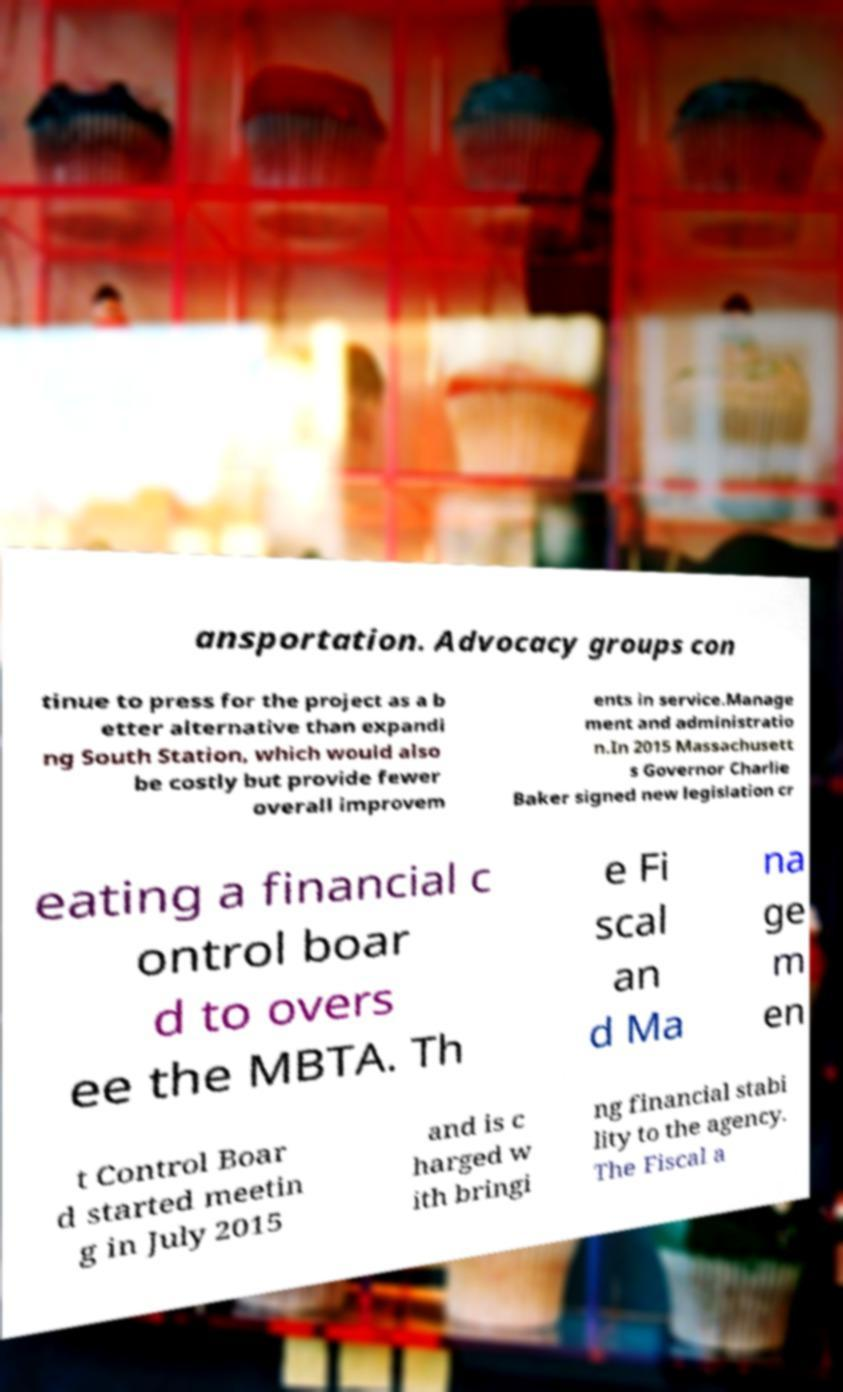Can you accurately transcribe the text from the provided image for me? ansportation. Advocacy groups con tinue to press for the project as a b etter alternative than expandi ng South Station, which would also be costly but provide fewer overall improvem ents in service.Manage ment and administratio n.In 2015 Massachusett s Governor Charlie Baker signed new legislation cr eating a financial c ontrol boar d to overs ee the MBTA. Th e Fi scal an d Ma na ge m en t Control Boar d started meetin g in July 2015 and is c harged w ith bringi ng financial stabi lity to the agency. The Fiscal a 